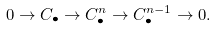Convert formula to latex. <formula><loc_0><loc_0><loc_500><loc_500>0 \rightarrow C _ { \bullet } \rightarrow C _ { \bullet } ^ { n } \rightarrow C _ { \bullet } ^ { n - 1 } \rightarrow 0 .</formula> 